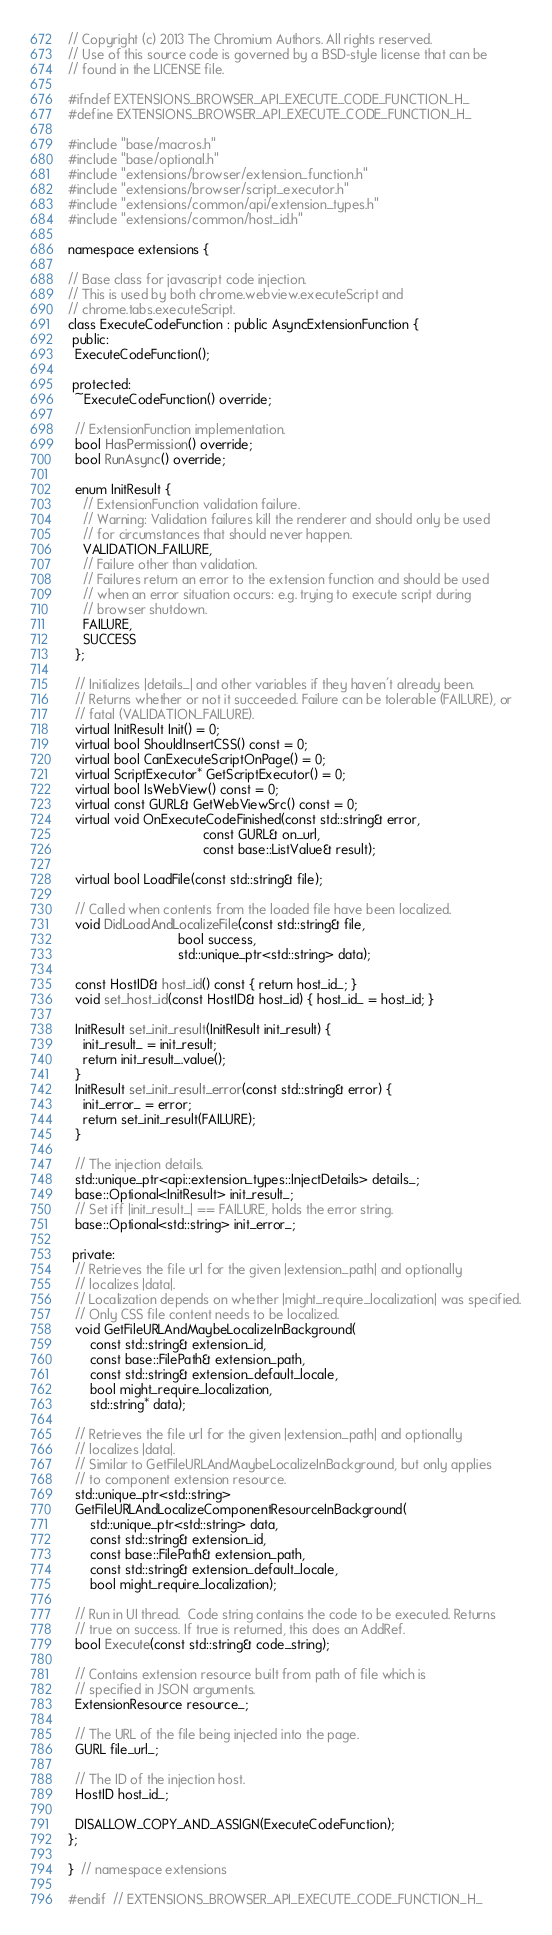Convert code to text. <code><loc_0><loc_0><loc_500><loc_500><_C_>// Copyright (c) 2013 The Chromium Authors. All rights reserved.
// Use of this source code is governed by a BSD-style license that can be
// found in the LICENSE file.

#ifndef EXTENSIONS_BROWSER_API_EXECUTE_CODE_FUNCTION_H_
#define EXTENSIONS_BROWSER_API_EXECUTE_CODE_FUNCTION_H_

#include "base/macros.h"
#include "base/optional.h"
#include "extensions/browser/extension_function.h"
#include "extensions/browser/script_executor.h"
#include "extensions/common/api/extension_types.h"
#include "extensions/common/host_id.h"

namespace extensions {

// Base class for javascript code injection.
// This is used by both chrome.webview.executeScript and
// chrome.tabs.executeScript.
class ExecuteCodeFunction : public AsyncExtensionFunction {
 public:
  ExecuteCodeFunction();

 protected:
  ~ExecuteCodeFunction() override;

  // ExtensionFunction implementation.
  bool HasPermission() override;
  bool RunAsync() override;

  enum InitResult {
    // ExtensionFunction validation failure.
    // Warning: Validation failures kill the renderer and should only be used
    // for circumstances that should never happen.
    VALIDATION_FAILURE,
    // Failure other than validation.
    // Failures return an error to the extension function and should be used
    // when an error situation occurs: e.g. trying to execute script during
    // browser shutdown.
    FAILURE,
    SUCCESS
  };

  // Initializes |details_| and other variables if they haven't already been.
  // Returns whether or not it succeeded. Failure can be tolerable (FAILURE), or
  // fatal (VALIDATION_FAILURE).
  virtual InitResult Init() = 0;
  virtual bool ShouldInsertCSS() const = 0;
  virtual bool CanExecuteScriptOnPage() = 0;
  virtual ScriptExecutor* GetScriptExecutor() = 0;
  virtual bool IsWebView() const = 0;
  virtual const GURL& GetWebViewSrc() const = 0;
  virtual void OnExecuteCodeFinished(const std::string& error,
                                     const GURL& on_url,
                                     const base::ListValue& result);

  virtual bool LoadFile(const std::string& file);

  // Called when contents from the loaded file have been localized.
  void DidLoadAndLocalizeFile(const std::string& file,
                              bool success,
                              std::unique_ptr<std::string> data);

  const HostID& host_id() const { return host_id_; }
  void set_host_id(const HostID& host_id) { host_id_ = host_id; }

  InitResult set_init_result(InitResult init_result) {
    init_result_ = init_result;
    return init_result_.value();
  }
  InitResult set_init_result_error(const std::string& error) {
    init_error_ = error;
    return set_init_result(FAILURE);
  }

  // The injection details.
  std::unique_ptr<api::extension_types::InjectDetails> details_;
  base::Optional<InitResult> init_result_;
  // Set iff |init_result_| == FAILURE, holds the error string.
  base::Optional<std::string> init_error_;

 private:
  // Retrieves the file url for the given |extension_path| and optionally
  // localizes |data|.
  // Localization depends on whether |might_require_localization| was specified.
  // Only CSS file content needs to be localized.
  void GetFileURLAndMaybeLocalizeInBackground(
      const std::string& extension_id,
      const base::FilePath& extension_path,
      const std::string& extension_default_locale,
      bool might_require_localization,
      std::string* data);

  // Retrieves the file url for the given |extension_path| and optionally
  // localizes |data|.
  // Similar to GetFileURLAndMaybeLocalizeInBackground, but only applies
  // to component extension resource.
  std::unique_ptr<std::string>
  GetFileURLAndLocalizeComponentResourceInBackground(
      std::unique_ptr<std::string> data,
      const std::string& extension_id,
      const base::FilePath& extension_path,
      const std::string& extension_default_locale,
      bool might_require_localization);

  // Run in UI thread.  Code string contains the code to be executed. Returns
  // true on success. If true is returned, this does an AddRef.
  bool Execute(const std::string& code_string);

  // Contains extension resource built from path of file which is
  // specified in JSON arguments.
  ExtensionResource resource_;

  // The URL of the file being injected into the page.
  GURL file_url_;

  // The ID of the injection host.
  HostID host_id_;

  DISALLOW_COPY_AND_ASSIGN(ExecuteCodeFunction);
};

}  // namespace extensions

#endif  // EXTENSIONS_BROWSER_API_EXECUTE_CODE_FUNCTION_H_
</code> 